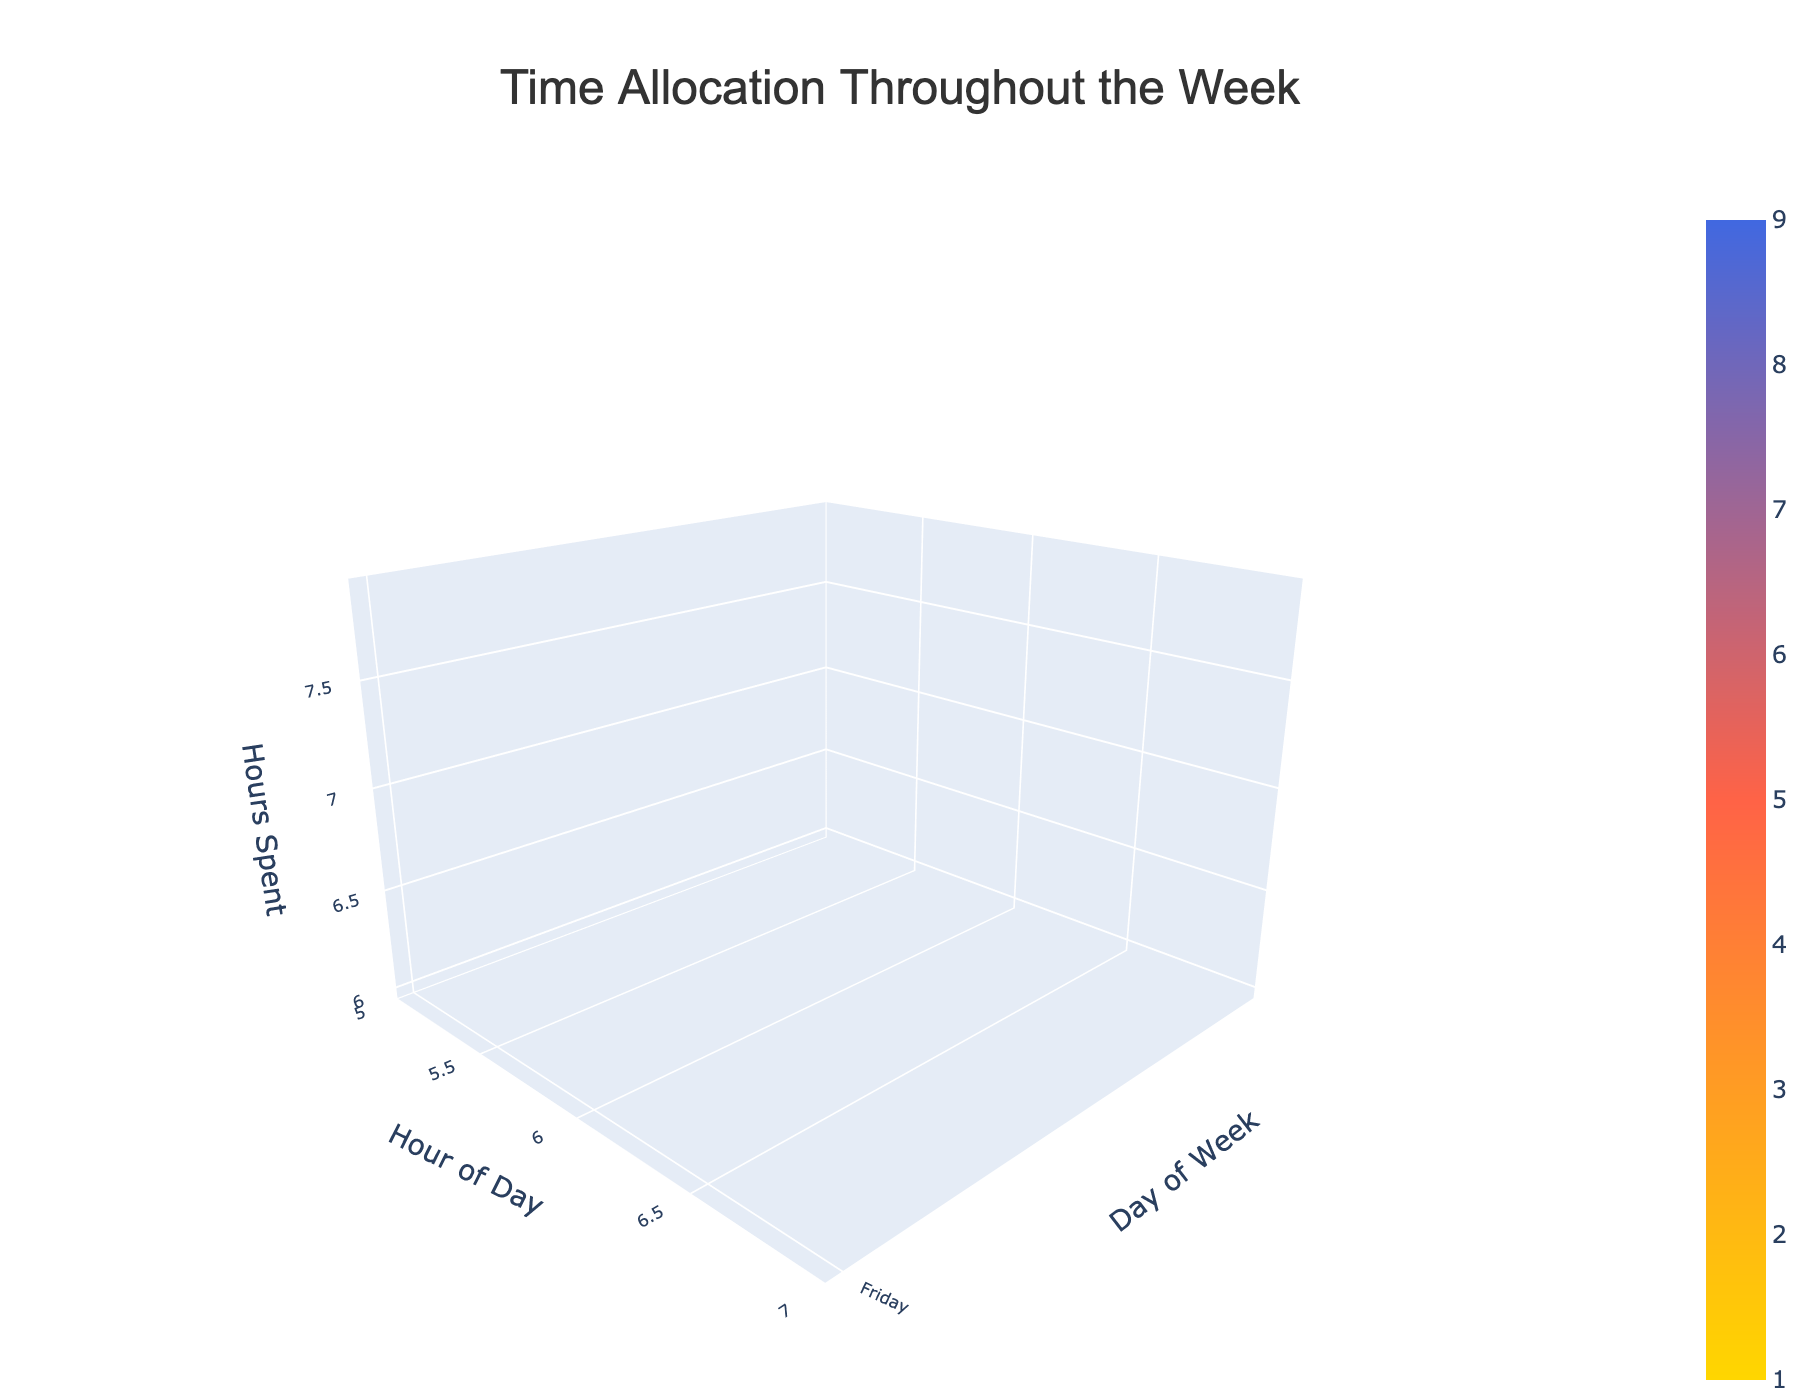What is the title of the figure? The title of the figure is displayed at the top and typically summarizes the overall data being visualized. Specifically, it focuses on time allocation throughout the week.
Answer: Time Allocation Throughout the Week Which day of the week has the highest hours spent on religious study? By examining the z-axis on the plot, look for the peak of "Religious_Study" category, it appears on Monday evening.
Answer: Monday How many hours are spent on childcare on Friday? Locate the Friday row on the y-axis and check the hours spent on childcare which occurs earlier in the day around noon.
Answer: 5 On which day is work the lowest, and how many hours are spent working on that day? Review the 'Work' hours across all days and identify the day with the least 'Work' hours, which is clearly reduced on Friday based on the z-values.
Answer: Friday, 6 hours How does the amount of hours spent on childcare compare between Monday and Tuesday? Compare the z-values of 'Childcare' category for Monday and Tuesday. Monday has 4 hours while Tuesday has 3 hours.
Answer: Monday has 1 more hour than Tuesday What is the combined total of hours spent on Work from Monday to Thursday? Sum the values of 'Work' from Monday to Thursday by adding up the respective z-values: 8 (Mon) + 9 (Tues) + 8 (Wed) + 9 (Thurs).
Answer: 34 hours During which hours on Saturday is time allocated to religious activities? Check the 'Religious_Activities' on the z-axis for Saturday, which involves 'Synagogue_Service' and 'Havdalah'. They are allocated in the morning and evening respectively.
Answer: 9 AM and 7 PM Compare the hours spent on work on Wednesday and Thursday. Which day has more work hours and by how much? Locate Wednesday and Thursday rows on the y-axis, then compare 'Work' values: Wednesday has 8 hours and Thursday has 9 hours.
Answer: Thursday by 1 hour Does the plot indicate any hours allocated to activities other than childcare and work on Friday? Observe the categorical allocations on Friday beyond 'Childcare' and 'Work' which includes 'Shabbat Preparation' in the evening.
Answer: Yes, Shabbat Preparation What is the average time spent on religious activities weekly? Identify all the hours dedicated to religious activities, sum them up (2+2+2+2+3+4+1+2) and divide by the number of instances (8).
Answer: 2 hours 